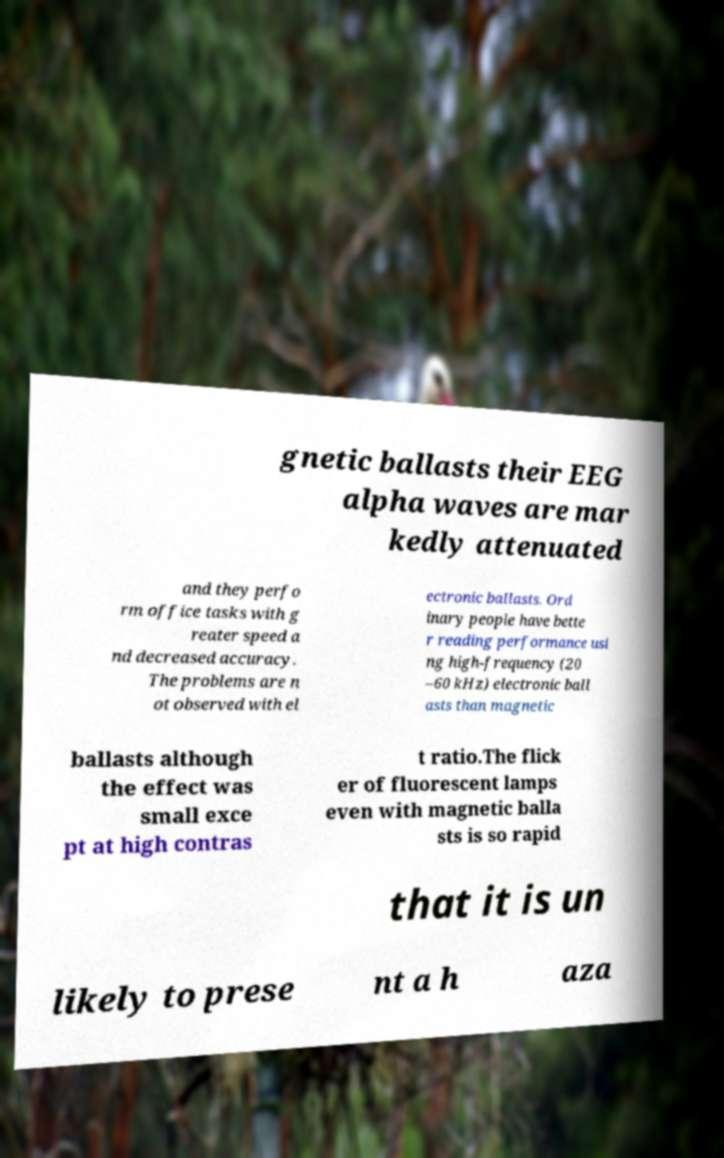Please read and relay the text visible in this image. What does it say? gnetic ballasts their EEG alpha waves are mar kedly attenuated and they perfo rm office tasks with g reater speed a nd decreased accuracy. The problems are n ot observed with el ectronic ballasts. Ord inary people have bette r reading performance usi ng high-frequency (20 –60 kHz) electronic ball asts than magnetic ballasts although the effect was small exce pt at high contras t ratio.The flick er of fluorescent lamps even with magnetic balla sts is so rapid that it is un likely to prese nt a h aza 